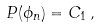Convert formula to latex. <formula><loc_0><loc_0><loc_500><loc_500>P ( \phi _ { n } ) = C _ { 1 } \, ,</formula> 